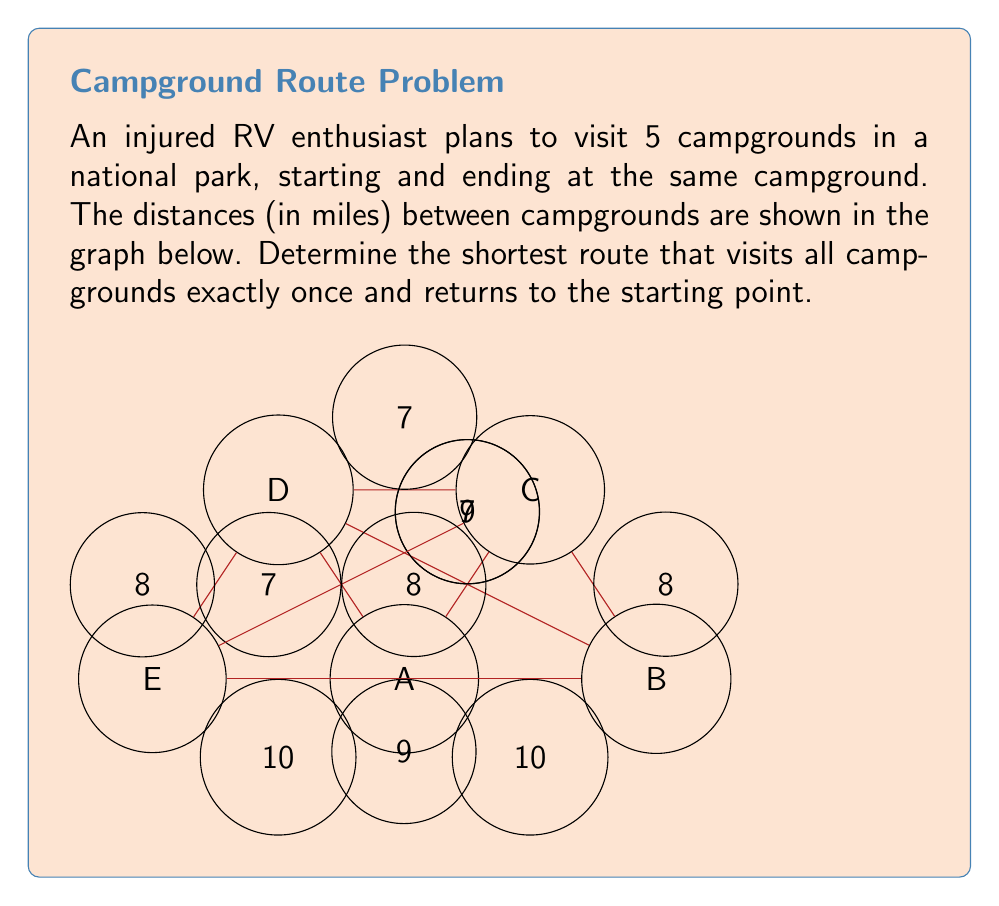What is the answer to this math problem? To solve this problem, we can use the Held-Karp algorithm, which is an exact method for solving the Traveling Salesman Problem (TSP) using dynamic programming. Here's a step-by-step explanation:

1) First, we need to create a distance matrix for our graph:

   $$
   \begin{bmatrix}
   0 & 10 & 7 & 7 & 10 \\
   10 & 0 & 8 & 9 & 9 \\
   7 & 8 & 0 & 7 & 8 \\
   7 & 9 & 7 & 0 & 8 \\
   10 & 9 & 8 & 8 & 0
   \end{bmatrix}
   $$

2) Initialize the base cases:
   For each campground $j \neq 1$, calculate $C(\{j\}, j) = d_{1j}$

3) For subsets $S$ of size 2 to $n-1$:
   For each $j \in S$:
   Calculate $C(S, j) = \min_{i \in S, i \neq j} [C(S - \{j\}, i) + d_{ij}]$

4) Finally, calculate the optimal tour length:
   $\text{opt} = \min_{j \neq 1} [C(\{2, 3, ..., n\}, j) + d_{j1}]$

5) After computing all values, we can backtrack to find the optimal tour.

Applying this algorithm to our graph:

Base cases:
$C(\{B\}, B) = 10$
$C(\{C\}, C) = 7$
$C(\{D\}, D) = 7$
$C(\{E\}, E) = 10$

For subsets of size 2:
$C(\{B,C\}, B) = 7 + 8 = 15$
$C(\{B,C\}, C) = 10 + 8 = 18$
...

Continuing this process for larger subsets, we eventually find:

$C(\{B,C,D,E\}, B) = 32$
$C(\{B,C,D,E\}, C) = 32$
$C(\{B,C,D,E\}, D) = 32$
$C(\{B,C,D,E\}, E) = 32$

The optimal tour length is:
$\text{opt} = \min(32 + 10, 32 + 7, 32 + 7, 32 + 10) = 39$

Backtracking, we find the optimal tour: A → C → D → E → B → A
Answer: 39 miles (A → C → D → E → B → A) 